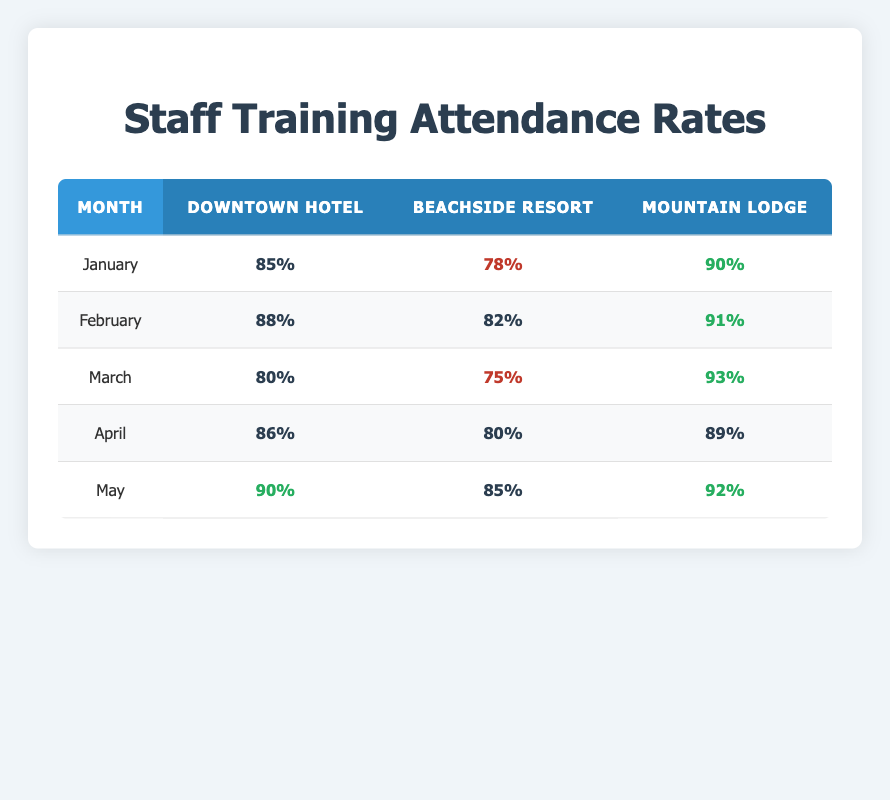What was the highest attendance rate recorded in January? In January, the attendance rates are 85%, 78%, and 90% for Downtown Hotel, Beachside Resort, and Mountain Lodge, respectively. The highest value among these is 90%.
Answer: 90% What was the attendance rate for Beachside Resort in April? Looking at the table, the attendance rate for Beachside Resort in April is listed as 80%.
Answer: 80% Which location had the lowest attendance rate in March? In March, the attendance rates are 80%, 75%, and 93% for Downtown Hotel, Beachside Resort, and Mountain Lodge, respectively. Beachside Resort has the lowest attendance rate at 75%.
Answer: 75% What is the average attendance rate for Mountain Lodge across all months? The attendance rates for Mountain Lodge are 90%, 91%, 93%, 89%, and 92%. The total is 90 + 91 + 93 + 89 + 92 = 455. Since there are 5 months, the average is 455 / 5 = 91.
Answer: 91 Did the attendance rate for Downtown Hotel increase from January to February? In January, the attendance rate for Downtown Hotel was 85%, and in February, it was 88%. Since 88% is greater than 85%, the attendance rate did increase.
Answer: Yes What was the change in attendance rate for Beachside Resort from February to March? The attendance rate for Beachside Resort in February was 82%, and in March it dropped to 75%. The change is calculated as 75 - 82 = -7, indicating a decrease.
Answer: Decrease Across the five months, how many times did Mountain Lodge have an attendance rate above 90%? Analyzing the table, Mountain Lodge had attendance rates of 90%, 91%, 93%, 89%, and 92%. The rates above 90% are 91%, 93%, and 92%, totaling three instances.
Answer: 3 In which month did the Downtown Hotel record the highest attendance rate? The attendance rates for Downtown Hotel by month are 85%, 88%, 80%, 86%, and 90%. The highest value is 90%, which occurred in May.
Answer: May 